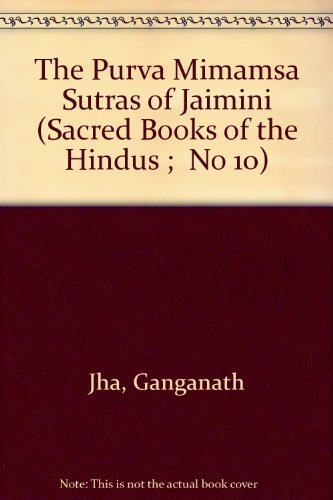Could this book be used as a primary source for academic research? Yes, this book could serve as a primary source for academic research particularly in the fields of religious studies, philosophy, and Indology. It offers a translation and perhaps commentary on the Mimamsa Sutras, which are foundational texts for understanding the Mimamsa school of thought within Hindu philosophy. 